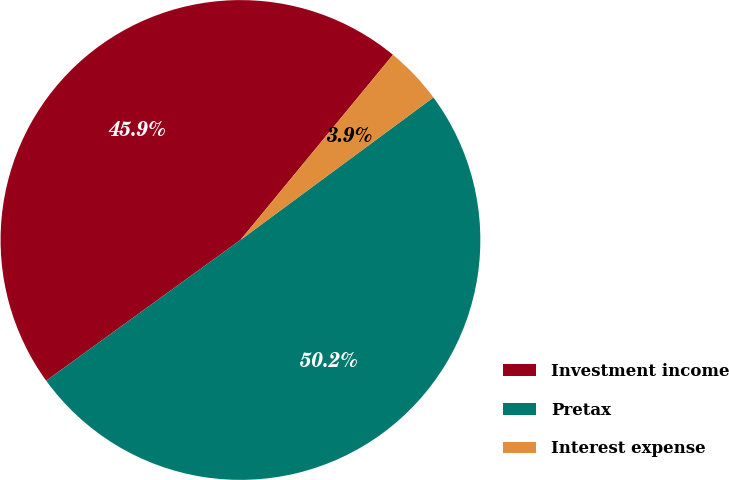<chart> <loc_0><loc_0><loc_500><loc_500><pie_chart><fcel>Investment income<fcel>Pretax<fcel>Interest expense<nl><fcel>45.94%<fcel>50.15%<fcel>3.91%<nl></chart> 